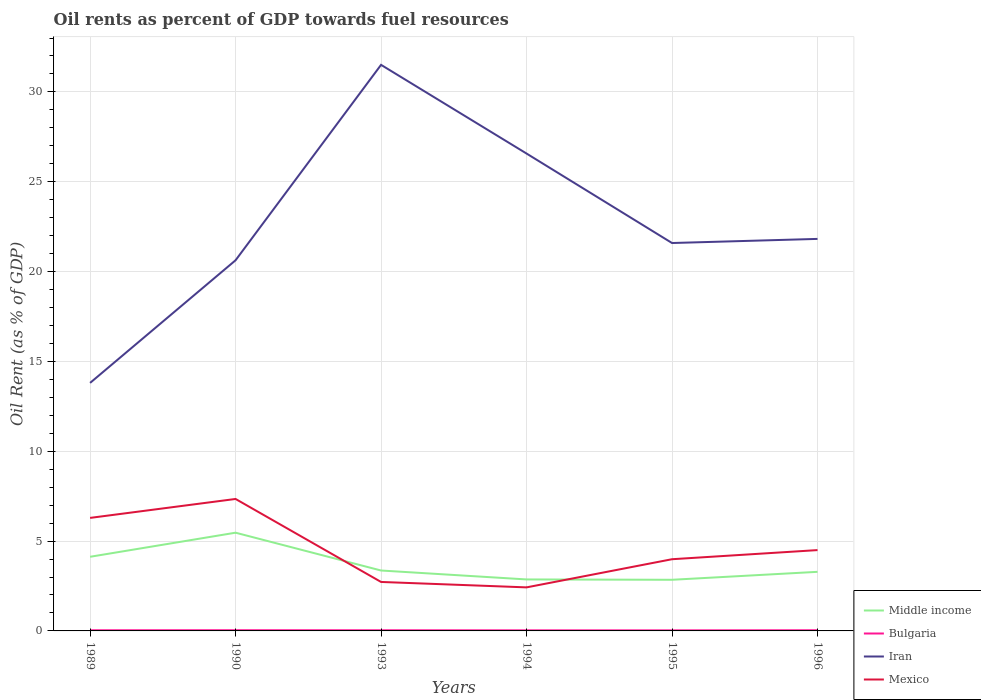How many different coloured lines are there?
Provide a short and direct response. 4. Across all years, what is the maximum oil rent in Iran?
Your response must be concise. 13.8. In which year was the oil rent in Iran maximum?
Offer a terse response. 1989. What is the total oil rent in Bulgaria in the graph?
Provide a short and direct response. 0.01. What is the difference between the highest and the second highest oil rent in Mexico?
Your answer should be compact. 4.92. What is the difference between the highest and the lowest oil rent in Mexico?
Your answer should be very brief. 2. Is the oil rent in Iran strictly greater than the oil rent in Middle income over the years?
Your response must be concise. No. How many years are there in the graph?
Offer a terse response. 6. Are the values on the major ticks of Y-axis written in scientific E-notation?
Make the answer very short. No. Does the graph contain grids?
Provide a short and direct response. Yes. Where does the legend appear in the graph?
Provide a succinct answer. Bottom right. How many legend labels are there?
Offer a very short reply. 4. How are the legend labels stacked?
Offer a terse response. Vertical. What is the title of the graph?
Provide a short and direct response. Oil rents as percent of GDP towards fuel resources. Does "Ethiopia" appear as one of the legend labels in the graph?
Give a very brief answer. No. What is the label or title of the Y-axis?
Give a very brief answer. Oil Rent (as % of GDP). What is the Oil Rent (as % of GDP) in Middle income in 1989?
Give a very brief answer. 4.13. What is the Oil Rent (as % of GDP) in Bulgaria in 1989?
Provide a succinct answer. 0.04. What is the Oil Rent (as % of GDP) in Iran in 1989?
Your answer should be very brief. 13.8. What is the Oil Rent (as % of GDP) of Mexico in 1989?
Your response must be concise. 6.29. What is the Oil Rent (as % of GDP) of Middle income in 1990?
Keep it short and to the point. 5.47. What is the Oil Rent (as % of GDP) in Bulgaria in 1990?
Ensure brevity in your answer.  0.04. What is the Oil Rent (as % of GDP) of Iran in 1990?
Your answer should be compact. 20.63. What is the Oil Rent (as % of GDP) in Mexico in 1990?
Give a very brief answer. 7.34. What is the Oil Rent (as % of GDP) in Middle income in 1993?
Offer a terse response. 3.36. What is the Oil Rent (as % of GDP) in Bulgaria in 1993?
Give a very brief answer. 0.04. What is the Oil Rent (as % of GDP) in Iran in 1993?
Make the answer very short. 31.51. What is the Oil Rent (as % of GDP) of Mexico in 1993?
Keep it short and to the point. 2.73. What is the Oil Rent (as % of GDP) of Middle income in 1994?
Ensure brevity in your answer.  2.87. What is the Oil Rent (as % of GDP) in Bulgaria in 1994?
Your answer should be compact. 0.03. What is the Oil Rent (as % of GDP) in Iran in 1994?
Offer a very short reply. 26.57. What is the Oil Rent (as % of GDP) in Mexico in 1994?
Keep it short and to the point. 2.42. What is the Oil Rent (as % of GDP) in Middle income in 1995?
Your answer should be compact. 2.85. What is the Oil Rent (as % of GDP) of Bulgaria in 1995?
Keep it short and to the point. 0.03. What is the Oil Rent (as % of GDP) of Iran in 1995?
Offer a terse response. 21.59. What is the Oil Rent (as % of GDP) of Mexico in 1995?
Provide a short and direct response. 3.99. What is the Oil Rent (as % of GDP) of Middle income in 1996?
Provide a short and direct response. 3.29. What is the Oil Rent (as % of GDP) of Bulgaria in 1996?
Your answer should be compact. 0.04. What is the Oil Rent (as % of GDP) of Iran in 1996?
Offer a very short reply. 21.82. What is the Oil Rent (as % of GDP) of Mexico in 1996?
Provide a succinct answer. 4.5. Across all years, what is the maximum Oil Rent (as % of GDP) in Middle income?
Offer a very short reply. 5.47. Across all years, what is the maximum Oil Rent (as % of GDP) in Bulgaria?
Provide a short and direct response. 0.04. Across all years, what is the maximum Oil Rent (as % of GDP) in Iran?
Give a very brief answer. 31.51. Across all years, what is the maximum Oil Rent (as % of GDP) in Mexico?
Ensure brevity in your answer.  7.34. Across all years, what is the minimum Oil Rent (as % of GDP) in Middle income?
Your answer should be very brief. 2.85. Across all years, what is the minimum Oil Rent (as % of GDP) in Bulgaria?
Provide a succinct answer. 0.03. Across all years, what is the minimum Oil Rent (as % of GDP) in Iran?
Your answer should be very brief. 13.8. Across all years, what is the minimum Oil Rent (as % of GDP) in Mexico?
Keep it short and to the point. 2.42. What is the total Oil Rent (as % of GDP) of Middle income in the graph?
Your response must be concise. 21.96. What is the total Oil Rent (as % of GDP) in Bulgaria in the graph?
Ensure brevity in your answer.  0.21. What is the total Oil Rent (as % of GDP) in Iran in the graph?
Provide a short and direct response. 135.92. What is the total Oil Rent (as % of GDP) in Mexico in the graph?
Provide a succinct answer. 27.27. What is the difference between the Oil Rent (as % of GDP) of Middle income in 1989 and that in 1990?
Your answer should be very brief. -1.34. What is the difference between the Oil Rent (as % of GDP) of Bulgaria in 1989 and that in 1990?
Provide a short and direct response. -0. What is the difference between the Oil Rent (as % of GDP) of Iran in 1989 and that in 1990?
Provide a short and direct response. -6.83. What is the difference between the Oil Rent (as % of GDP) in Mexico in 1989 and that in 1990?
Your answer should be compact. -1.05. What is the difference between the Oil Rent (as % of GDP) in Middle income in 1989 and that in 1993?
Provide a succinct answer. 0.76. What is the difference between the Oil Rent (as % of GDP) in Bulgaria in 1989 and that in 1993?
Give a very brief answer. -0. What is the difference between the Oil Rent (as % of GDP) in Iran in 1989 and that in 1993?
Provide a short and direct response. -17.7. What is the difference between the Oil Rent (as % of GDP) in Mexico in 1989 and that in 1993?
Offer a very short reply. 3.57. What is the difference between the Oil Rent (as % of GDP) in Middle income in 1989 and that in 1994?
Your answer should be compact. 1.26. What is the difference between the Oil Rent (as % of GDP) of Bulgaria in 1989 and that in 1994?
Offer a very short reply. 0. What is the difference between the Oil Rent (as % of GDP) in Iran in 1989 and that in 1994?
Offer a very short reply. -12.77. What is the difference between the Oil Rent (as % of GDP) of Mexico in 1989 and that in 1994?
Provide a short and direct response. 3.87. What is the difference between the Oil Rent (as % of GDP) of Middle income in 1989 and that in 1995?
Provide a short and direct response. 1.28. What is the difference between the Oil Rent (as % of GDP) of Bulgaria in 1989 and that in 1995?
Offer a terse response. 0.01. What is the difference between the Oil Rent (as % of GDP) in Iran in 1989 and that in 1995?
Give a very brief answer. -7.79. What is the difference between the Oil Rent (as % of GDP) in Mexico in 1989 and that in 1995?
Offer a very short reply. 2.3. What is the difference between the Oil Rent (as % of GDP) of Middle income in 1989 and that in 1996?
Your answer should be very brief. 0.84. What is the difference between the Oil Rent (as % of GDP) in Bulgaria in 1989 and that in 1996?
Make the answer very short. -0. What is the difference between the Oil Rent (as % of GDP) in Iran in 1989 and that in 1996?
Your answer should be compact. -8.01. What is the difference between the Oil Rent (as % of GDP) in Mexico in 1989 and that in 1996?
Your answer should be compact. 1.79. What is the difference between the Oil Rent (as % of GDP) of Middle income in 1990 and that in 1993?
Keep it short and to the point. 2.1. What is the difference between the Oil Rent (as % of GDP) of Bulgaria in 1990 and that in 1993?
Your response must be concise. 0. What is the difference between the Oil Rent (as % of GDP) of Iran in 1990 and that in 1993?
Offer a terse response. -10.88. What is the difference between the Oil Rent (as % of GDP) in Mexico in 1990 and that in 1993?
Ensure brevity in your answer.  4.62. What is the difference between the Oil Rent (as % of GDP) of Middle income in 1990 and that in 1994?
Keep it short and to the point. 2.6. What is the difference between the Oil Rent (as % of GDP) of Bulgaria in 1990 and that in 1994?
Your answer should be compact. 0.01. What is the difference between the Oil Rent (as % of GDP) in Iran in 1990 and that in 1994?
Provide a short and direct response. -5.94. What is the difference between the Oil Rent (as % of GDP) of Mexico in 1990 and that in 1994?
Ensure brevity in your answer.  4.92. What is the difference between the Oil Rent (as % of GDP) of Middle income in 1990 and that in 1995?
Your response must be concise. 2.62. What is the difference between the Oil Rent (as % of GDP) of Bulgaria in 1990 and that in 1995?
Offer a very short reply. 0.01. What is the difference between the Oil Rent (as % of GDP) of Iran in 1990 and that in 1995?
Offer a very short reply. -0.96. What is the difference between the Oil Rent (as % of GDP) of Mexico in 1990 and that in 1995?
Keep it short and to the point. 3.35. What is the difference between the Oil Rent (as % of GDP) in Middle income in 1990 and that in 1996?
Your answer should be compact. 2.18. What is the difference between the Oil Rent (as % of GDP) in Bulgaria in 1990 and that in 1996?
Make the answer very short. 0. What is the difference between the Oil Rent (as % of GDP) of Iran in 1990 and that in 1996?
Offer a terse response. -1.19. What is the difference between the Oil Rent (as % of GDP) in Mexico in 1990 and that in 1996?
Provide a short and direct response. 2.85. What is the difference between the Oil Rent (as % of GDP) of Middle income in 1993 and that in 1994?
Keep it short and to the point. 0.5. What is the difference between the Oil Rent (as % of GDP) of Bulgaria in 1993 and that in 1994?
Give a very brief answer. 0. What is the difference between the Oil Rent (as % of GDP) in Iran in 1993 and that in 1994?
Provide a short and direct response. 4.94. What is the difference between the Oil Rent (as % of GDP) in Mexico in 1993 and that in 1994?
Your answer should be very brief. 0.3. What is the difference between the Oil Rent (as % of GDP) in Middle income in 1993 and that in 1995?
Provide a short and direct response. 0.52. What is the difference between the Oil Rent (as % of GDP) of Bulgaria in 1993 and that in 1995?
Keep it short and to the point. 0.01. What is the difference between the Oil Rent (as % of GDP) of Iran in 1993 and that in 1995?
Provide a succinct answer. 9.92. What is the difference between the Oil Rent (as % of GDP) in Mexico in 1993 and that in 1995?
Offer a terse response. -1.27. What is the difference between the Oil Rent (as % of GDP) of Middle income in 1993 and that in 1996?
Offer a very short reply. 0.07. What is the difference between the Oil Rent (as % of GDP) in Bulgaria in 1993 and that in 1996?
Keep it short and to the point. -0. What is the difference between the Oil Rent (as % of GDP) in Iran in 1993 and that in 1996?
Offer a very short reply. 9.69. What is the difference between the Oil Rent (as % of GDP) of Mexico in 1993 and that in 1996?
Keep it short and to the point. -1.77. What is the difference between the Oil Rent (as % of GDP) in Middle income in 1994 and that in 1995?
Your answer should be very brief. 0.02. What is the difference between the Oil Rent (as % of GDP) of Bulgaria in 1994 and that in 1995?
Provide a short and direct response. 0. What is the difference between the Oil Rent (as % of GDP) in Iran in 1994 and that in 1995?
Keep it short and to the point. 4.98. What is the difference between the Oil Rent (as % of GDP) in Mexico in 1994 and that in 1995?
Ensure brevity in your answer.  -1.57. What is the difference between the Oil Rent (as % of GDP) in Middle income in 1994 and that in 1996?
Your answer should be very brief. -0.42. What is the difference between the Oil Rent (as % of GDP) in Bulgaria in 1994 and that in 1996?
Make the answer very short. -0.01. What is the difference between the Oil Rent (as % of GDP) of Iran in 1994 and that in 1996?
Make the answer very short. 4.75. What is the difference between the Oil Rent (as % of GDP) in Mexico in 1994 and that in 1996?
Your response must be concise. -2.08. What is the difference between the Oil Rent (as % of GDP) of Middle income in 1995 and that in 1996?
Your response must be concise. -0.44. What is the difference between the Oil Rent (as % of GDP) in Bulgaria in 1995 and that in 1996?
Offer a very short reply. -0.01. What is the difference between the Oil Rent (as % of GDP) of Iran in 1995 and that in 1996?
Your answer should be compact. -0.23. What is the difference between the Oil Rent (as % of GDP) of Mexico in 1995 and that in 1996?
Offer a terse response. -0.51. What is the difference between the Oil Rent (as % of GDP) in Middle income in 1989 and the Oil Rent (as % of GDP) in Bulgaria in 1990?
Your response must be concise. 4.09. What is the difference between the Oil Rent (as % of GDP) in Middle income in 1989 and the Oil Rent (as % of GDP) in Iran in 1990?
Offer a terse response. -16.5. What is the difference between the Oil Rent (as % of GDP) of Middle income in 1989 and the Oil Rent (as % of GDP) of Mexico in 1990?
Your answer should be compact. -3.22. What is the difference between the Oil Rent (as % of GDP) in Bulgaria in 1989 and the Oil Rent (as % of GDP) in Iran in 1990?
Give a very brief answer. -20.59. What is the difference between the Oil Rent (as % of GDP) of Bulgaria in 1989 and the Oil Rent (as % of GDP) of Mexico in 1990?
Ensure brevity in your answer.  -7.31. What is the difference between the Oil Rent (as % of GDP) of Iran in 1989 and the Oil Rent (as % of GDP) of Mexico in 1990?
Give a very brief answer. 6.46. What is the difference between the Oil Rent (as % of GDP) in Middle income in 1989 and the Oil Rent (as % of GDP) in Bulgaria in 1993?
Offer a terse response. 4.09. What is the difference between the Oil Rent (as % of GDP) of Middle income in 1989 and the Oil Rent (as % of GDP) of Iran in 1993?
Your answer should be very brief. -27.38. What is the difference between the Oil Rent (as % of GDP) in Middle income in 1989 and the Oil Rent (as % of GDP) in Mexico in 1993?
Provide a succinct answer. 1.4. What is the difference between the Oil Rent (as % of GDP) in Bulgaria in 1989 and the Oil Rent (as % of GDP) in Iran in 1993?
Provide a succinct answer. -31.47. What is the difference between the Oil Rent (as % of GDP) of Bulgaria in 1989 and the Oil Rent (as % of GDP) of Mexico in 1993?
Your response must be concise. -2.69. What is the difference between the Oil Rent (as % of GDP) in Iran in 1989 and the Oil Rent (as % of GDP) in Mexico in 1993?
Give a very brief answer. 11.08. What is the difference between the Oil Rent (as % of GDP) in Middle income in 1989 and the Oil Rent (as % of GDP) in Bulgaria in 1994?
Keep it short and to the point. 4.09. What is the difference between the Oil Rent (as % of GDP) of Middle income in 1989 and the Oil Rent (as % of GDP) of Iran in 1994?
Ensure brevity in your answer.  -22.44. What is the difference between the Oil Rent (as % of GDP) of Middle income in 1989 and the Oil Rent (as % of GDP) of Mexico in 1994?
Keep it short and to the point. 1.7. What is the difference between the Oil Rent (as % of GDP) in Bulgaria in 1989 and the Oil Rent (as % of GDP) in Iran in 1994?
Provide a short and direct response. -26.53. What is the difference between the Oil Rent (as % of GDP) in Bulgaria in 1989 and the Oil Rent (as % of GDP) in Mexico in 1994?
Your answer should be compact. -2.39. What is the difference between the Oil Rent (as % of GDP) in Iran in 1989 and the Oil Rent (as % of GDP) in Mexico in 1994?
Ensure brevity in your answer.  11.38. What is the difference between the Oil Rent (as % of GDP) in Middle income in 1989 and the Oil Rent (as % of GDP) in Bulgaria in 1995?
Ensure brevity in your answer.  4.1. What is the difference between the Oil Rent (as % of GDP) in Middle income in 1989 and the Oil Rent (as % of GDP) in Iran in 1995?
Your response must be concise. -17.46. What is the difference between the Oil Rent (as % of GDP) in Middle income in 1989 and the Oil Rent (as % of GDP) in Mexico in 1995?
Provide a succinct answer. 0.14. What is the difference between the Oil Rent (as % of GDP) of Bulgaria in 1989 and the Oil Rent (as % of GDP) of Iran in 1995?
Make the answer very short. -21.55. What is the difference between the Oil Rent (as % of GDP) of Bulgaria in 1989 and the Oil Rent (as % of GDP) of Mexico in 1995?
Provide a short and direct response. -3.95. What is the difference between the Oil Rent (as % of GDP) of Iran in 1989 and the Oil Rent (as % of GDP) of Mexico in 1995?
Provide a succinct answer. 9.81. What is the difference between the Oil Rent (as % of GDP) in Middle income in 1989 and the Oil Rent (as % of GDP) in Bulgaria in 1996?
Provide a succinct answer. 4.09. What is the difference between the Oil Rent (as % of GDP) of Middle income in 1989 and the Oil Rent (as % of GDP) of Iran in 1996?
Your answer should be very brief. -17.69. What is the difference between the Oil Rent (as % of GDP) in Middle income in 1989 and the Oil Rent (as % of GDP) in Mexico in 1996?
Keep it short and to the point. -0.37. What is the difference between the Oil Rent (as % of GDP) in Bulgaria in 1989 and the Oil Rent (as % of GDP) in Iran in 1996?
Keep it short and to the point. -21.78. What is the difference between the Oil Rent (as % of GDP) in Bulgaria in 1989 and the Oil Rent (as % of GDP) in Mexico in 1996?
Your answer should be compact. -4.46. What is the difference between the Oil Rent (as % of GDP) in Iran in 1989 and the Oil Rent (as % of GDP) in Mexico in 1996?
Offer a terse response. 9.31. What is the difference between the Oil Rent (as % of GDP) in Middle income in 1990 and the Oil Rent (as % of GDP) in Bulgaria in 1993?
Give a very brief answer. 5.43. What is the difference between the Oil Rent (as % of GDP) of Middle income in 1990 and the Oil Rent (as % of GDP) of Iran in 1993?
Provide a succinct answer. -26.04. What is the difference between the Oil Rent (as % of GDP) of Middle income in 1990 and the Oil Rent (as % of GDP) of Mexico in 1993?
Offer a very short reply. 2.74. What is the difference between the Oil Rent (as % of GDP) of Bulgaria in 1990 and the Oil Rent (as % of GDP) of Iran in 1993?
Give a very brief answer. -31.47. What is the difference between the Oil Rent (as % of GDP) in Bulgaria in 1990 and the Oil Rent (as % of GDP) in Mexico in 1993?
Keep it short and to the point. -2.69. What is the difference between the Oil Rent (as % of GDP) in Iran in 1990 and the Oil Rent (as % of GDP) in Mexico in 1993?
Your response must be concise. 17.9. What is the difference between the Oil Rent (as % of GDP) in Middle income in 1990 and the Oil Rent (as % of GDP) in Bulgaria in 1994?
Ensure brevity in your answer.  5.44. What is the difference between the Oil Rent (as % of GDP) in Middle income in 1990 and the Oil Rent (as % of GDP) in Iran in 1994?
Offer a terse response. -21.1. What is the difference between the Oil Rent (as % of GDP) in Middle income in 1990 and the Oil Rent (as % of GDP) in Mexico in 1994?
Offer a very short reply. 3.04. What is the difference between the Oil Rent (as % of GDP) in Bulgaria in 1990 and the Oil Rent (as % of GDP) in Iran in 1994?
Keep it short and to the point. -26.53. What is the difference between the Oil Rent (as % of GDP) in Bulgaria in 1990 and the Oil Rent (as % of GDP) in Mexico in 1994?
Make the answer very short. -2.38. What is the difference between the Oil Rent (as % of GDP) in Iran in 1990 and the Oil Rent (as % of GDP) in Mexico in 1994?
Your answer should be very brief. 18.21. What is the difference between the Oil Rent (as % of GDP) of Middle income in 1990 and the Oil Rent (as % of GDP) of Bulgaria in 1995?
Keep it short and to the point. 5.44. What is the difference between the Oil Rent (as % of GDP) of Middle income in 1990 and the Oil Rent (as % of GDP) of Iran in 1995?
Make the answer very short. -16.12. What is the difference between the Oil Rent (as % of GDP) in Middle income in 1990 and the Oil Rent (as % of GDP) in Mexico in 1995?
Make the answer very short. 1.48. What is the difference between the Oil Rent (as % of GDP) of Bulgaria in 1990 and the Oil Rent (as % of GDP) of Iran in 1995?
Offer a terse response. -21.55. What is the difference between the Oil Rent (as % of GDP) in Bulgaria in 1990 and the Oil Rent (as % of GDP) in Mexico in 1995?
Provide a short and direct response. -3.95. What is the difference between the Oil Rent (as % of GDP) in Iran in 1990 and the Oil Rent (as % of GDP) in Mexico in 1995?
Your response must be concise. 16.64. What is the difference between the Oil Rent (as % of GDP) in Middle income in 1990 and the Oil Rent (as % of GDP) in Bulgaria in 1996?
Provide a short and direct response. 5.43. What is the difference between the Oil Rent (as % of GDP) in Middle income in 1990 and the Oil Rent (as % of GDP) in Iran in 1996?
Give a very brief answer. -16.35. What is the difference between the Oil Rent (as % of GDP) of Middle income in 1990 and the Oil Rent (as % of GDP) of Mexico in 1996?
Your answer should be very brief. 0.97. What is the difference between the Oil Rent (as % of GDP) of Bulgaria in 1990 and the Oil Rent (as % of GDP) of Iran in 1996?
Your response must be concise. -21.78. What is the difference between the Oil Rent (as % of GDP) of Bulgaria in 1990 and the Oil Rent (as % of GDP) of Mexico in 1996?
Your answer should be very brief. -4.46. What is the difference between the Oil Rent (as % of GDP) in Iran in 1990 and the Oil Rent (as % of GDP) in Mexico in 1996?
Offer a very short reply. 16.13. What is the difference between the Oil Rent (as % of GDP) in Middle income in 1993 and the Oil Rent (as % of GDP) in Bulgaria in 1994?
Ensure brevity in your answer.  3.33. What is the difference between the Oil Rent (as % of GDP) of Middle income in 1993 and the Oil Rent (as % of GDP) of Iran in 1994?
Your response must be concise. -23.21. What is the difference between the Oil Rent (as % of GDP) of Middle income in 1993 and the Oil Rent (as % of GDP) of Mexico in 1994?
Offer a very short reply. 0.94. What is the difference between the Oil Rent (as % of GDP) in Bulgaria in 1993 and the Oil Rent (as % of GDP) in Iran in 1994?
Provide a short and direct response. -26.53. What is the difference between the Oil Rent (as % of GDP) in Bulgaria in 1993 and the Oil Rent (as % of GDP) in Mexico in 1994?
Ensure brevity in your answer.  -2.39. What is the difference between the Oil Rent (as % of GDP) of Iran in 1993 and the Oil Rent (as % of GDP) of Mexico in 1994?
Keep it short and to the point. 29.08. What is the difference between the Oil Rent (as % of GDP) of Middle income in 1993 and the Oil Rent (as % of GDP) of Bulgaria in 1995?
Offer a very short reply. 3.33. What is the difference between the Oil Rent (as % of GDP) in Middle income in 1993 and the Oil Rent (as % of GDP) in Iran in 1995?
Offer a very short reply. -18.23. What is the difference between the Oil Rent (as % of GDP) of Middle income in 1993 and the Oil Rent (as % of GDP) of Mexico in 1995?
Ensure brevity in your answer.  -0.63. What is the difference between the Oil Rent (as % of GDP) of Bulgaria in 1993 and the Oil Rent (as % of GDP) of Iran in 1995?
Your response must be concise. -21.55. What is the difference between the Oil Rent (as % of GDP) of Bulgaria in 1993 and the Oil Rent (as % of GDP) of Mexico in 1995?
Keep it short and to the point. -3.95. What is the difference between the Oil Rent (as % of GDP) in Iran in 1993 and the Oil Rent (as % of GDP) in Mexico in 1995?
Offer a terse response. 27.52. What is the difference between the Oil Rent (as % of GDP) in Middle income in 1993 and the Oil Rent (as % of GDP) in Bulgaria in 1996?
Provide a short and direct response. 3.33. What is the difference between the Oil Rent (as % of GDP) of Middle income in 1993 and the Oil Rent (as % of GDP) of Iran in 1996?
Your response must be concise. -18.46. What is the difference between the Oil Rent (as % of GDP) of Middle income in 1993 and the Oil Rent (as % of GDP) of Mexico in 1996?
Your response must be concise. -1.14. What is the difference between the Oil Rent (as % of GDP) in Bulgaria in 1993 and the Oil Rent (as % of GDP) in Iran in 1996?
Offer a very short reply. -21.78. What is the difference between the Oil Rent (as % of GDP) in Bulgaria in 1993 and the Oil Rent (as % of GDP) in Mexico in 1996?
Your answer should be very brief. -4.46. What is the difference between the Oil Rent (as % of GDP) in Iran in 1993 and the Oil Rent (as % of GDP) in Mexico in 1996?
Offer a very short reply. 27.01. What is the difference between the Oil Rent (as % of GDP) in Middle income in 1994 and the Oil Rent (as % of GDP) in Bulgaria in 1995?
Offer a very short reply. 2.83. What is the difference between the Oil Rent (as % of GDP) of Middle income in 1994 and the Oil Rent (as % of GDP) of Iran in 1995?
Keep it short and to the point. -18.72. What is the difference between the Oil Rent (as % of GDP) in Middle income in 1994 and the Oil Rent (as % of GDP) in Mexico in 1995?
Your answer should be very brief. -1.13. What is the difference between the Oil Rent (as % of GDP) of Bulgaria in 1994 and the Oil Rent (as % of GDP) of Iran in 1995?
Provide a succinct answer. -21.56. What is the difference between the Oil Rent (as % of GDP) of Bulgaria in 1994 and the Oil Rent (as % of GDP) of Mexico in 1995?
Your response must be concise. -3.96. What is the difference between the Oil Rent (as % of GDP) in Iran in 1994 and the Oil Rent (as % of GDP) in Mexico in 1995?
Offer a very short reply. 22.58. What is the difference between the Oil Rent (as % of GDP) in Middle income in 1994 and the Oil Rent (as % of GDP) in Bulgaria in 1996?
Ensure brevity in your answer.  2.83. What is the difference between the Oil Rent (as % of GDP) in Middle income in 1994 and the Oil Rent (as % of GDP) in Iran in 1996?
Your answer should be very brief. -18.95. What is the difference between the Oil Rent (as % of GDP) of Middle income in 1994 and the Oil Rent (as % of GDP) of Mexico in 1996?
Provide a succinct answer. -1.63. What is the difference between the Oil Rent (as % of GDP) in Bulgaria in 1994 and the Oil Rent (as % of GDP) in Iran in 1996?
Offer a very short reply. -21.79. What is the difference between the Oil Rent (as % of GDP) of Bulgaria in 1994 and the Oil Rent (as % of GDP) of Mexico in 1996?
Give a very brief answer. -4.47. What is the difference between the Oil Rent (as % of GDP) of Iran in 1994 and the Oil Rent (as % of GDP) of Mexico in 1996?
Provide a succinct answer. 22.07. What is the difference between the Oil Rent (as % of GDP) of Middle income in 1995 and the Oil Rent (as % of GDP) of Bulgaria in 1996?
Ensure brevity in your answer.  2.81. What is the difference between the Oil Rent (as % of GDP) of Middle income in 1995 and the Oil Rent (as % of GDP) of Iran in 1996?
Your answer should be very brief. -18.97. What is the difference between the Oil Rent (as % of GDP) of Middle income in 1995 and the Oil Rent (as % of GDP) of Mexico in 1996?
Ensure brevity in your answer.  -1.65. What is the difference between the Oil Rent (as % of GDP) of Bulgaria in 1995 and the Oil Rent (as % of GDP) of Iran in 1996?
Your answer should be compact. -21.79. What is the difference between the Oil Rent (as % of GDP) in Bulgaria in 1995 and the Oil Rent (as % of GDP) in Mexico in 1996?
Ensure brevity in your answer.  -4.47. What is the difference between the Oil Rent (as % of GDP) in Iran in 1995 and the Oil Rent (as % of GDP) in Mexico in 1996?
Offer a terse response. 17.09. What is the average Oil Rent (as % of GDP) of Middle income per year?
Offer a very short reply. 3.66. What is the average Oil Rent (as % of GDP) of Bulgaria per year?
Offer a terse response. 0.04. What is the average Oil Rent (as % of GDP) in Iran per year?
Offer a very short reply. 22.65. What is the average Oil Rent (as % of GDP) of Mexico per year?
Offer a very short reply. 4.55. In the year 1989, what is the difference between the Oil Rent (as % of GDP) in Middle income and Oil Rent (as % of GDP) in Bulgaria?
Your response must be concise. 4.09. In the year 1989, what is the difference between the Oil Rent (as % of GDP) of Middle income and Oil Rent (as % of GDP) of Iran?
Your answer should be compact. -9.68. In the year 1989, what is the difference between the Oil Rent (as % of GDP) in Middle income and Oil Rent (as % of GDP) in Mexico?
Keep it short and to the point. -2.16. In the year 1989, what is the difference between the Oil Rent (as % of GDP) of Bulgaria and Oil Rent (as % of GDP) of Iran?
Provide a short and direct response. -13.77. In the year 1989, what is the difference between the Oil Rent (as % of GDP) of Bulgaria and Oil Rent (as % of GDP) of Mexico?
Give a very brief answer. -6.25. In the year 1989, what is the difference between the Oil Rent (as % of GDP) in Iran and Oil Rent (as % of GDP) in Mexico?
Your answer should be compact. 7.51. In the year 1990, what is the difference between the Oil Rent (as % of GDP) in Middle income and Oil Rent (as % of GDP) in Bulgaria?
Ensure brevity in your answer.  5.43. In the year 1990, what is the difference between the Oil Rent (as % of GDP) of Middle income and Oil Rent (as % of GDP) of Iran?
Make the answer very short. -15.16. In the year 1990, what is the difference between the Oil Rent (as % of GDP) in Middle income and Oil Rent (as % of GDP) in Mexico?
Your response must be concise. -1.88. In the year 1990, what is the difference between the Oil Rent (as % of GDP) of Bulgaria and Oil Rent (as % of GDP) of Iran?
Give a very brief answer. -20.59. In the year 1990, what is the difference between the Oil Rent (as % of GDP) in Bulgaria and Oil Rent (as % of GDP) in Mexico?
Provide a succinct answer. -7.3. In the year 1990, what is the difference between the Oil Rent (as % of GDP) in Iran and Oil Rent (as % of GDP) in Mexico?
Provide a short and direct response. 13.29. In the year 1993, what is the difference between the Oil Rent (as % of GDP) of Middle income and Oil Rent (as % of GDP) of Bulgaria?
Offer a terse response. 3.33. In the year 1993, what is the difference between the Oil Rent (as % of GDP) in Middle income and Oil Rent (as % of GDP) in Iran?
Your answer should be very brief. -28.14. In the year 1993, what is the difference between the Oil Rent (as % of GDP) in Middle income and Oil Rent (as % of GDP) in Mexico?
Offer a very short reply. 0.64. In the year 1993, what is the difference between the Oil Rent (as % of GDP) in Bulgaria and Oil Rent (as % of GDP) in Iran?
Ensure brevity in your answer.  -31.47. In the year 1993, what is the difference between the Oil Rent (as % of GDP) in Bulgaria and Oil Rent (as % of GDP) in Mexico?
Your response must be concise. -2.69. In the year 1993, what is the difference between the Oil Rent (as % of GDP) of Iran and Oil Rent (as % of GDP) of Mexico?
Ensure brevity in your answer.  28.78. In the year 1994, what is the difference between the Oil Rent (as % of GDP) of Middle income and Oil Rent (as % of GDP) of Bulgaria?
Provide a short and direct response. 2.83. In the year 1994, what is the difference between the Oil Rent (as % of GDP) of Middle income and Oil Rent (as % of GDP) of Iran?
Offer a very short reply. -23.7. In the year 1994, what is the difference between the Oil Rent (as % of GDP) in Middle income and Oil Rent (as % of GDP) in Mexico?
Provide a short and direct response. 0.44. In the year 1994, what is the difference between the Oil Rent (as % of GDP) of Bulgaria and Oil Rent (as % of GDP) of Iran?
Provide a short and direct response. -26.54. In the year 1994, what is the difference between the Oil Rent (as % of GDP) in Bulgaria and Oil Rent (as % of GDP) in Mexico?
Ensure brevity in your answer.  -2.39. In the year 1994, what is the difference between the Oil Rent (as % of GDP) of Iran and Oil Rent (as % of GDP) of Mexico?
Offer a very short reply. 24.15. In the year 1995, what is the difference between the Oil Rent (as % of GDP) of Middle income and Oil Rent (as % of GDP) of Bulgaria?
Your answer should be compact. 2.82. In the year 1995, what is the difference between the Oil Rent (as % of GDP) in Middle income and Oil Rent (as % of GDP) in Iran?
Give a very brief answer. -18.74. In the year 1995, what is the difference between the Oil Rent (as % of GDP) of Middle income and Oil Rent (as % of GDP) of Mexico?
Offer a very short reply. -1.14. In the year 1995, what is the difference between the Oil Rent (as % of GDP) of Bulgaria and Oil Rent (as % of GDP) of Iran?
Offer a terse response. -21.56. In the year 1995, what is the difference between the Oil Rent (as % of GDP) in Bulgaria and Oil Rent (as % of GDP) in Mexico?
Provide a short and direct response. -3.96. In the year 1995, what is the difference between the Oil Rent (as % of GDP) of Iran and Oil Rent (as % of GDP) of Mexico?
Your response must be concise. 17.6. In the year 1996, what is the difference between the Oil Rent (as % of GDP) in Middle income and Oil Rent (as % of GDP) in Bulgaria?
Offer a terse response. 3.25. In the year 1996, what is the difference between the Oil Rent (as % of GDP) of Middle income and Oil Rent (as % of GDP) of Iran?
Your answer should be very brief. -18.53. In the year 1996, what is the difference between the Oil Rent (as % of GDP) in Middle income and Oil Rent (as % of GDP) in Mexico?
Offer a terse response. -1.21. In the year 1996, what is the difference between the Oil Rent (as % of GDP) of Bulgaria and Oil Rent (as % of GDP) of Iran?
Offer a very short reply. -21.78. In the year 1996, what is the difference between the Oil Rent (as % of GDP) in Bulgaria and Oil Rent (as % of GDP) in Mexico?
Ensure brevity in your answer.  -4.46. In the year 1996, what is the difference between the Oil Rent (as % of GDP) of Iran and Oil Rent (as % of GDP) of Mexico?
Offer a very short reply. 17.32. What is the ratio of the Oil Rent (as % of GDP) of Middle income in 1989 to that in 1990?
Ensure brevity in your answer.  0.75. What is the ratio of the Oil Rent (as % of GDP) of Bulgaria in 1989 to that in 1990?
Keep it short and to the point. 0.91. What is the ratio of the Oil Rent (as % of GDP) in Iran in 1989 to that in 1990?
Provide a succinct answer. 0.67. What is the ratio of the Oil Rent (as % of GDP) in Mexico in 1989 to that in 1990?
Give a very brief answer. 0.86. What is the ratio of the Oil Rent (as % of GDP) in Middle income in 1989 to that in 1993?
Your answer should be compact. 1.23. What is the ratio of the Oil Rent (as % of GDP) of Bulgaria in 1989 to that in 1993?
Give a very brief answer. 0.99. What is the ratio of the Oil Rent (as % of GDP) of Iran in 1989 to that in 1993?
Provide a short and direct response. 0.44. What is the ratio of the Oil Rent (as % of GDP) in Mexico in 1989 to that in 1993?
Your answer should be very brief. 2.31. What is the ratio of the Oil Rent (as % of GDP) in Middle income in 1989 to that in 1994?
Give a very brief answer. 1.44. What is the ratio of the Oil Rent (as % of GDP) of Bulgaria in 1989 to that in 1994?
Your answer should be very brief. 1.14. What is the ratio of the Oil Rent (as % of GDP) in Iran in 1989 to that in 1994?
Your response must be concise. 0.52. What is the ratio of the Oil Rent (as % of GDP) in Mexico in 1989 to that in 1994?
Your answer should be compact. 2.6. What is the ratio of the Oil Rent (as % of GDP) in Middle income in 1989 to that in 1995?
Your answer should be compact. 1.45. What is the ratio of the Oil Rent (as % of GDP) of Bulgaria in 1989 to that in 1995?
Make the answer very short. 1.16. What is the ratio of the Oil Rent (as % of GDP) in Iran in 1989 to that in 1995?
Ensure brevity in your answer.  0.64. What is the ratio of the Oil Rent (as % of GDP) in Mexico in 1989 to that in 1995?
Provide a succinct answer. 1.58. What is the ratio of the Oil Rent (as % of GDP) in Middle income in 1989 to that in 1996?
Make the answer very short. 1.25. What is the ratio of the Oil Rent (as % of GDP) of Bulgaria in 1989 to that in 1996?
Make the answer very short. 0.97. What is the ratio of the Oil Rent (as % of GDP) in Iran in 1989 to that in 1996?
Your answer should be compact. 0.63. What is the ratio of the Oil Rent (as % of GDP) in Mexico in 1989 to that in 1996?
Your answer should be very brief. 1.4. What is the ratio of the Oil Rent (as % of GDP) of Middle income in 1990 to that in 1993?
Give a very brief answer. 1.63. What is the ratio of the Oil Rent (as % of GDP) in Bulgaria in 1990 to that in 1993?
Ensure brevity in your answer.  1.08. What is the ratio of the Oil Rent (as % of GDP) in Iran in 1990 to that in 1993?
Keep it short and to the point. 0.65. What is the ratio of the Oil Rent (as % of GDP) of Mexico in 1990 to that in 1993?
Keep it short and to the point. 2.69. What is the ratio of the Oil Rent (as % of GDP) of Middle income in 1990 to that in 1994?
Make the answer very short. 1.91. What is the ratio of the Oil Rent (as % of GDP) in Bulgaria in 1990 to that in 1994?
Offer a terse response. 1.24. What is the ratio of the Oil Rent (as % of GDP) of Iran in 1990 to that in 1994?
Provide a succinct answer. 0.78. What is the ratio of the Oil Rent (as % of GDP) of Mexico in 1990 to that in 1994?
Offer a very short reply. 3.03. What is the ratio of the Oil Rent (as % of GDP) in Middle income in 1990 to that in 1995?
Give a very brief answer. 1.92. What is the ratio of the Oil Rent (as % of GDP) of Bulgaria in 1990 to that in 1995?
Your answer should be compact. 1.27. What is the ratio of the Oil Rent (as % of GDP) in Iran in 1990 to that in 1995?
Provide a short and direct response. 0.96. What is the ratio of the Oil Rent (as % of GDP) of Mexico in 1990 to that in 1995?
Your response must be concise. 1.84. What is the ratio of the Oil Rent (as % of GDP) of Middle income in 1990 to that in 1996?
Offer a terse response. 1.66. What is the ratio of the Oil Rent (as % of GDP) in Bulgaria in 1990 to that in 1996?
Offer a very short reply. 1.06. What is the ratio of the Oil Rent (as % of GDP) of Iran in 1990 to that in 1996?
Keep it short and to the point. 0.95. What is the ratio of the Oil Rent (as % of GDP) of Mexico in 1990 to that in 1996?
Keep it short and to the point. 1.63. What is the ratio of the Oil Rent (as % of GDP) in Middle income in 1993 to that in 1994?
Give a very brief answer. 1.17. What is the ratio of the Oil Rent (as % of GDP) in Bulgaria in 1993 to that in 1994?
Offer a very short reply. 1.15. What is the ratio of the Oil Rent (as % of GDP) of Iran in 1993 to that in 1994?
Provide a short and direct response. 1.19. What is the ratio of the Oil Rent (as % of GDP) of Mexico in 1993 to that in 1994?
Offer a very short reply. 1.12. What is the ratio of the Oil Rent (as % of GDP) in Middle income in 1993 to that in 1995?
Keep it short and to the point. 1.18. What is the ratio of the Oil Rent (as % of GDP) in Bulgaria in 1993 to that in 1995?
Provide a succinct answer. 1.17. What is the ratio of the Oil Rent (as % of GDP) in Iran in 1993 to that in 1995?
Offer a very short reply. 1.46. What is the ratio of the Oil Rent (as % of GDP) in Mexico in 1993 to that in 1995?
Your answer should be compact. 0.68. What is the ratio of the Oil Rent (as % of GDP) of Middle income in 1993 to that in 1996?
Your answer should be compact. 1.02. What is the ratio of the Oil Rent (as % of GDP) of Bulgaria in 1993 to that in 1996?
Give a very brief answer. 0.98. What is the ratio of the Oil Rent (as % of GDP) in Iran in 1993 to that in 1996?
Give a very brief answer. 1.44. What is the ratio of the Oil Rent (as % of GDP) in Mexico in 1993 to that in 1996?
Make the answer very short. 0.61. What is the ratio of the Oil Rent (as % of GDP) of Middle income in 1994 to that in 1995?
Provide a succinct answer. 1.01. What is the ratio of the Oil Rent (as % of GDP) in Bulgaria in 1994 to that in 1995?
Offer a terse response. 1.02. What is the ratio of the Oil Rent (as % of GDP) of Iran in 1994 to that in 1995?
Your answer should be very brief. 1.23. What is the ratio of the Oil Rent (as % of GDP) in Mexico in 1994 to that in 1995?
Your answer should be very brief. 0.61. What is the ratio of the Oil Rent (as % of GDP) in Middle income in 1994 to that in 1996?
Your answer should be very brief. 0.87. What is the ratio of the Oil Rent (as % of GDP) of Bulgaria in 1994 to that in 1996?
Provide a succinct answer. 0.85. What is the ratio of the Oil Rent (as % of GDP) of Iran in 1994 to that in 1996?
Make the answer very short. 1.22. What is the ratio of the Oil Rent (as % of GDP) of Mexico in 1994 to that in 1996?
Make the answer very short. 0.54. What is the ratio of the Oil Rent (as % of GDP) in Middle income in 1995 to that in 1996?
Your response must be concise. 0.87. What is the ratio of the Oil Rent (as % of GDP) of Bulgaria in 1995 to that in 1996?
Offer a very short reply. 0.84. What is the ratio of the Oil Rent (as % of GDP) in Iran in 1995 to that in 1996?
Ensure brevity in your answer.  0.99. What is the ratio of the Oil Rent (as % of GDP) of Mexico in 1995 to that in 1996?
Your response must be concise. 0.89. What is the difference between the highest and the second highest Oil Rent (as % of GDP) of Middle income?
Your answer should be compact. 1.34. What is the difference between the highest and the second highest Oil Rent (as % of GDP) in Bulgaria?
Keep it short and to the point. 0. What is the difference between the highest and the second highest Oil Rent (as % of GDP) of Iran?
Offer a terse response. 4.94. What is the difference between the highest and the second highest Oil Rent (as % of GDP) in Mexico?
Give a very brief answer. 1.05. What is the difference between the highest and the lowest Oil Rent (as % of GDP) in Middle income?
Make the answer very short. 2.62. What is the difference between the highest and the lowest Oil Rent (as % of GDP) in Bulgaria?
Offer a very short reply. 0.01. What is the difference between the highest and the lowest Oil Rent (as % of GDP) of Iran?
Offer a very short reply. 17.7. What is the difference between the highest and the lowest Oil Rent (as % of GDP) in Mexico?
Offer a very short reply. 4.92. 